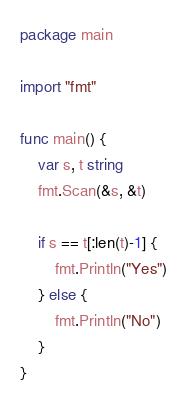Convert code to text. <code><loc_0><loc_0><loc_500><loc_500><_Go_>package main

import "fmt"

func main() {
	var s, t string
	fmt.Scan(&s, &t)

	if s == t[:len(t)-1] {
		fmt.Println("Yes")
	} else {
		fmt.Println("No")
	}
}
</code> 